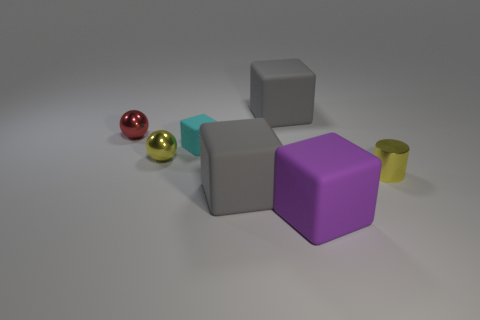Subtract all small blocks. How many blocks are left? 3 Subtract all cyan cubes. How many cubes are left? 3 Add 1 yellow shiny things. How many objects exist? 8 Subtract all blocks. How many objects are left? 3 Subtract 1 cylinders. How many cylinders are left? 0 Subtract all red spheres. Subtract all cyan cubes. How many spheres are left? 1 Subtract all brown balls. How many gray blocks are left? 2 Subtract all large metallic balls. Subtract all yellow things. How many objects are left? 5 Add 5 tiny yellow spheres. How many tiny yellow spheres are left? 6 Add 7 small red shiny spheres. How many small red shiny spheres exist? 8 